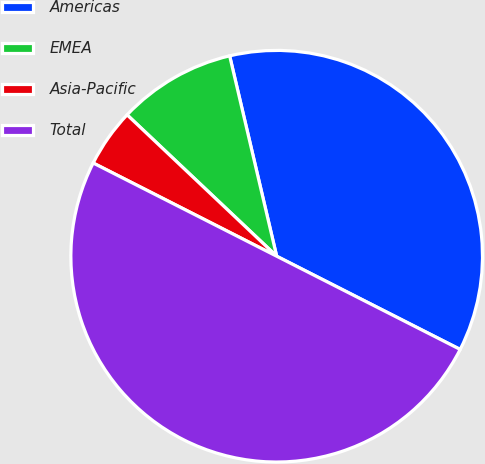Convert chart to OTSL. <chart><loc_0><loc_0><loc_500><loc_500><pie_chart><fcel>Americas<fcel>EMEA<fcel>Asia-Pacific<fcel>Total<nl><fcel>36.15%<fcel>9.28%<fcel>4.57%<fcel>50.0%<nl></chart> 